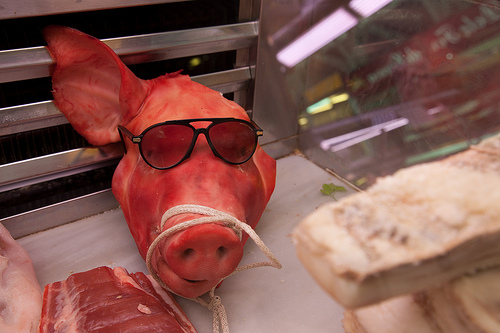<image>
Is there a sunglasses on the snout? Yes. Looking at the image, I can see the sunglasses is positioned on top of the snout, with the snout providing support. Is there a sunglass behind the rope? Yes. From this viewpoint, the sunglass is positioned behind the rope, with the rope partially or fully occluding the sunglass. Is there a sunglass to the right of the pig? No. The sunglass is not to the right of the pig. The horizontal positioning shows a different relationship. 